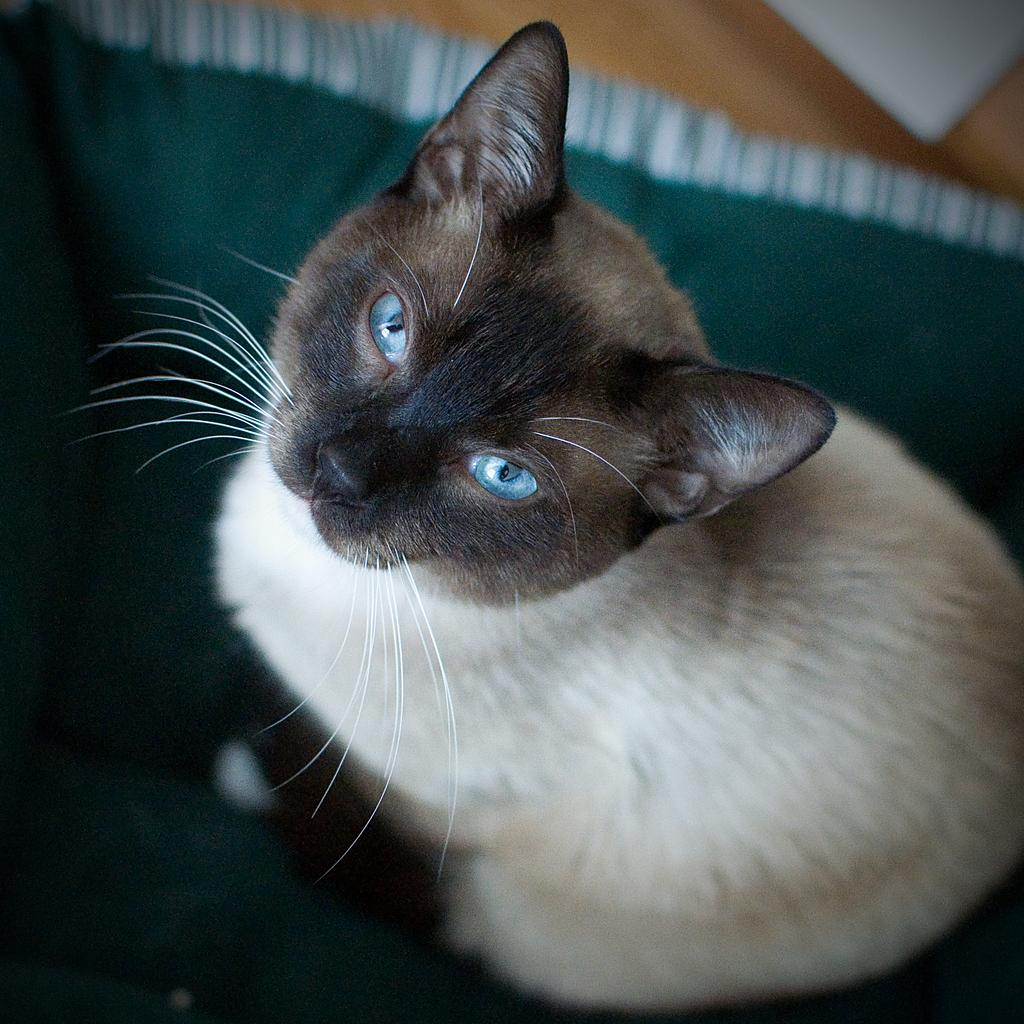What type of animal is in the image? There is a cat in the image. What is the cat sitting or lying on? The cat is on a cloth. What type of discovery is the cat making in the image? There is no indication of a discovery in the image; it simply shows a cat on a cloth. 